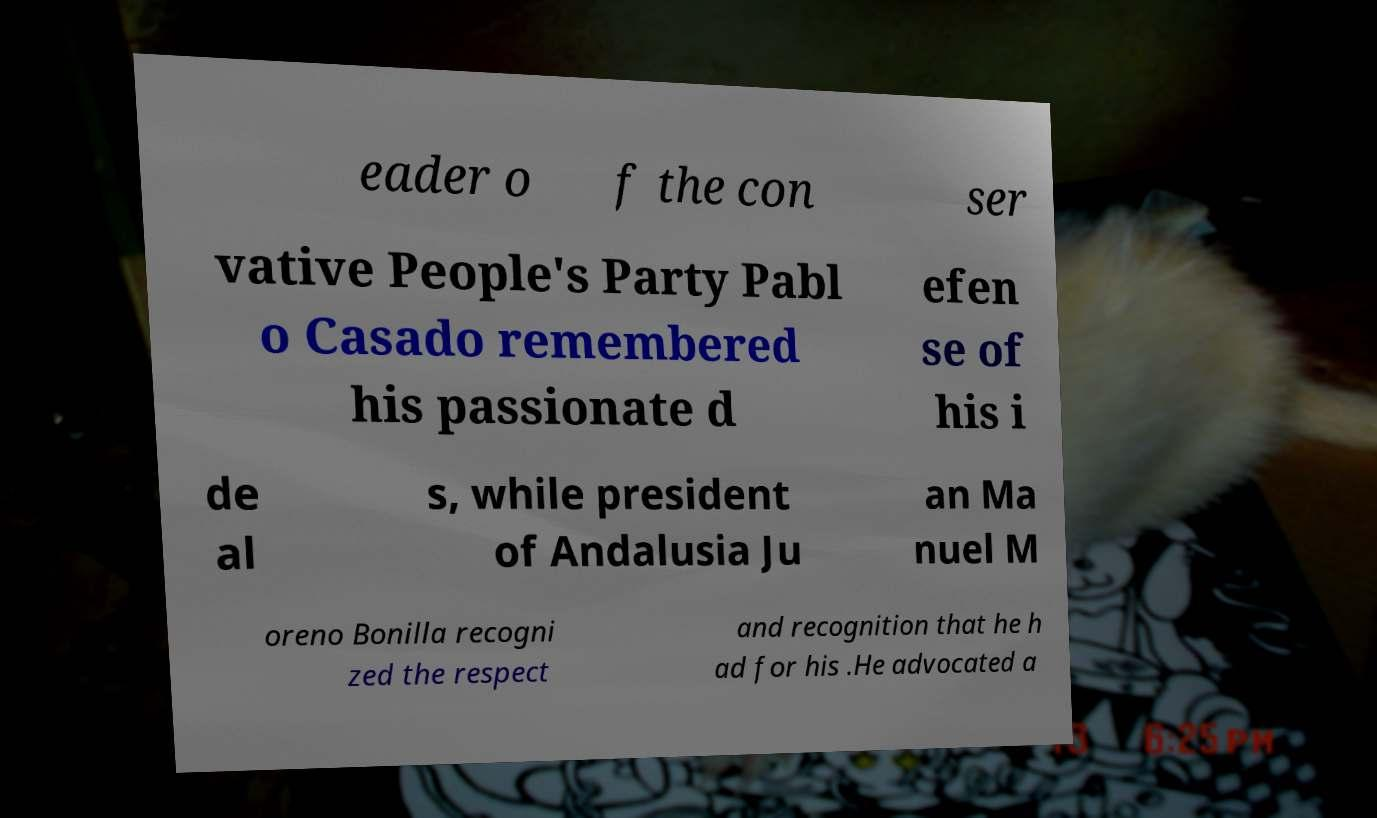What messages or text are displayed in this image? I need them in a readable, typed format. eader o f the con ser vative People's Party Pabl o Casado remembered his passionate d efen se of his i de al s, while president of Andalusia Ju an Ma nuel M oreno Bonilla recogni zed the respect and recognition that he h ad for his .He advocated a 